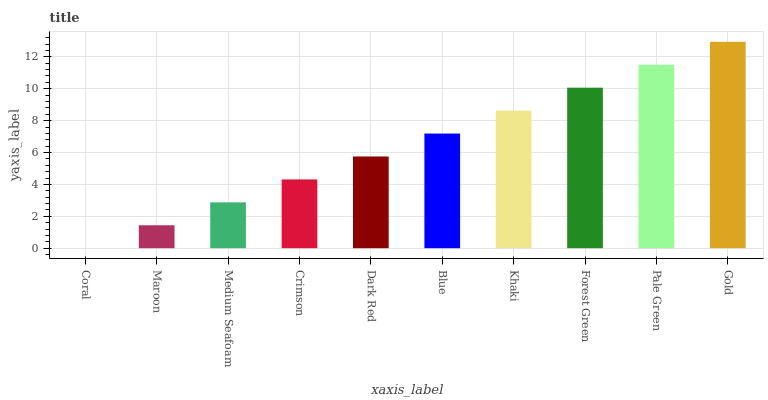Is Coral the minimum?
Answer yes or no. Yes. Is Gold the maximum?
Answer yes or no. Yes. Is Maroon the minimum?
Answer yes or no. No. Is Maroon the maximum?
Answer yes or no. No. Is Maroon greater than Coral?
Answer yes or no. Yes. Is Coral less than Maroon?
Answer yes or no. Yes. Is Coral greater than Maroon?
Answer yes or no. No. Is Maroon less than Coral?
Answer yes or no. No. Is Blue the high median?
Answer yes or no. Yes. Is Dark Red the low median?
Answer yes or no. Yes. Is Medium Seafoam the high median?
Answer yes or no. No. Is Pale Green the low median?
Answer yes or no. No. 